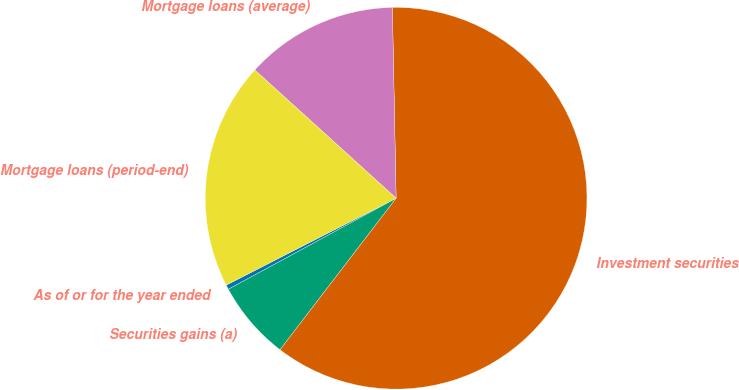<chart> <loc_0><loc_0><loc_500><loc_500><pie_chart><fcel>As of or for the year ended<fcel>Securities gains (a)<fcel>Investment securities<fcel>Mortgage loans (average)<fcel>Mortgage loans (period-end)<nl><fcel>0.39%<fcel>6.68%<fcel>60.72%<fcel>12.96%<fcel>19.25%<nl></chart> 